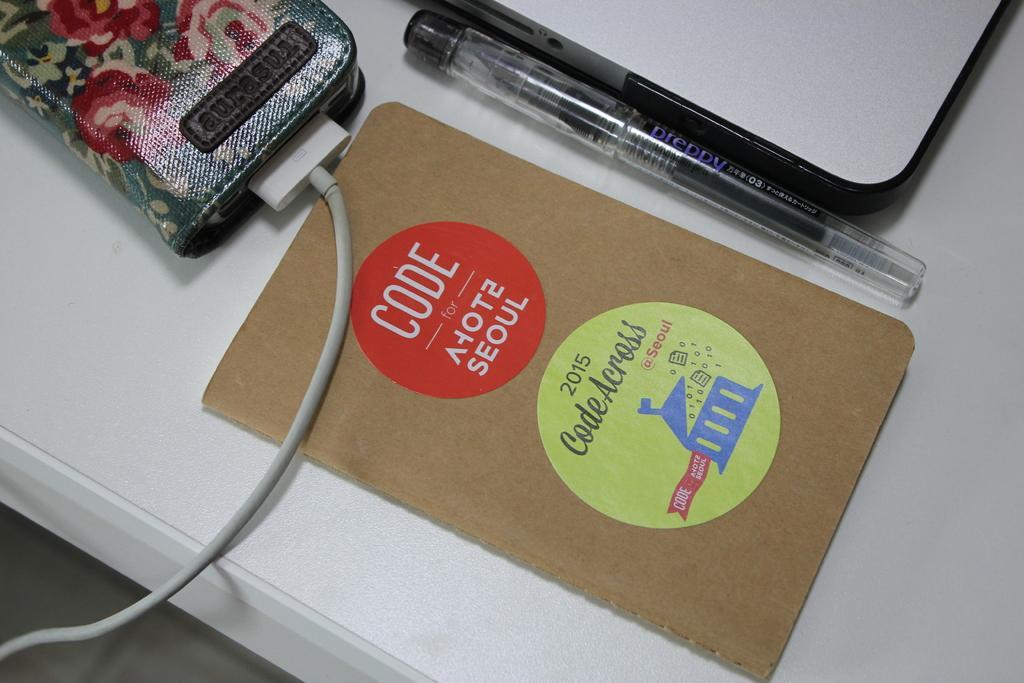In one or two sentences, can you explain what this image depicts? Here I can see a table on which I card, pen, two devices and a connector are placed. On the card, I can see some text. 